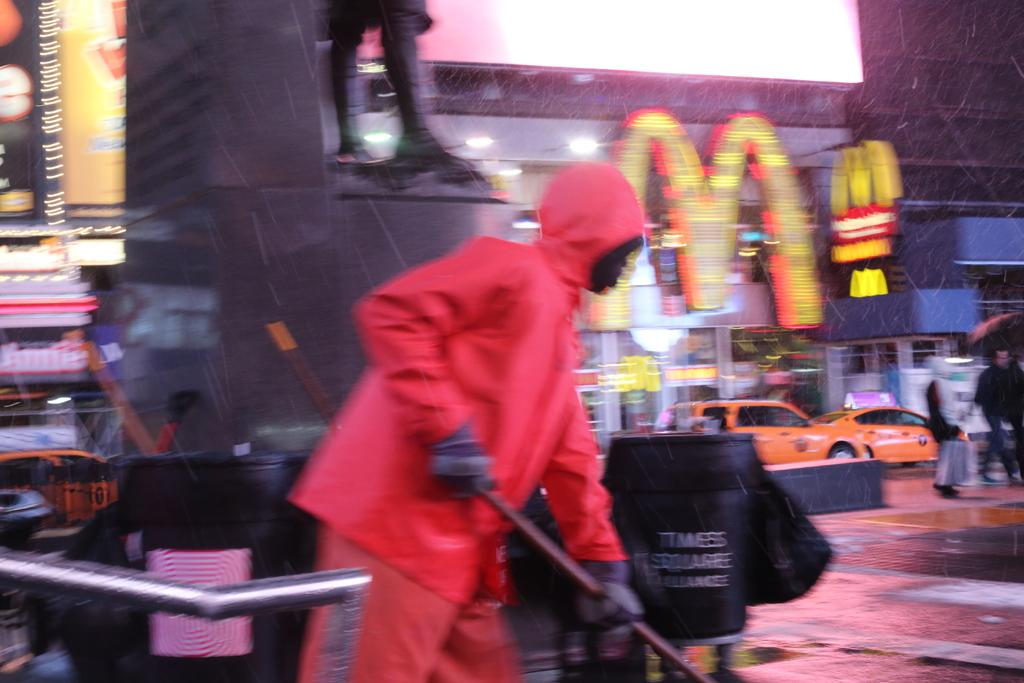Who is the person in the image? There is a man in the image. What is the man wearing? The man is wearing a pink dress. What is the man doing in the image? The man is cleaning the road. What can be seen in the background of the image? There are buildings and cars in the background of the image. What is at the bottom of the image? There is a road at the bottom of the image. What type of mint can be seen growing on the leaf in the image? There is no mint or leaf present in the image. 